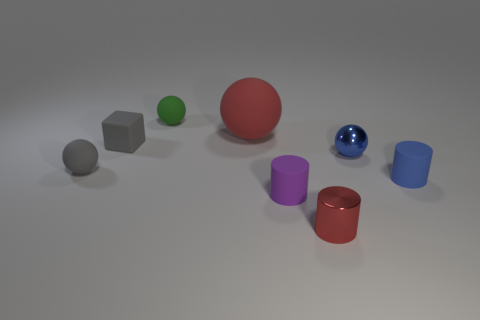What number of other things are there of the same size as the red shiny cylinder?
Offer a terse response. 6. There is a shiny cylinder; does it have the same color as the big sphere behind the small red thing?
Your answer should be very brief. Yes. How many things are either blue metal spheres or green matte things?
Your answer should be very brief. 2. Are there any other things that have the same color as the small metallic ball?
Offer a very short reply. Yes. Is the material of the tiny green ball the same as the small gray thing that is to the right of the gray ball?
Your answer should be compact. Yes. The tiny thing behind the matte ball to the right of the tiny green ball is what shape?
Make the answer very short. Sphere. There is a small matte thing that is both right of the small green rubber sphere and to the left of the small blue ball; what shape is it?
Offer a terse response. Cylinder. What number of things are either red cylinders or tiny objects that are right of the small green sphere?
Ensure brevity in your answer.  4. What is the material of the gray object that is the same shape as the small green rubber object?
Offer a terse response. Rubber. There is a small thing that is both in front of the blue sphere and behind the tiny blue rubber object; what material is it made of?
Give a very brief answer. Rubber. 